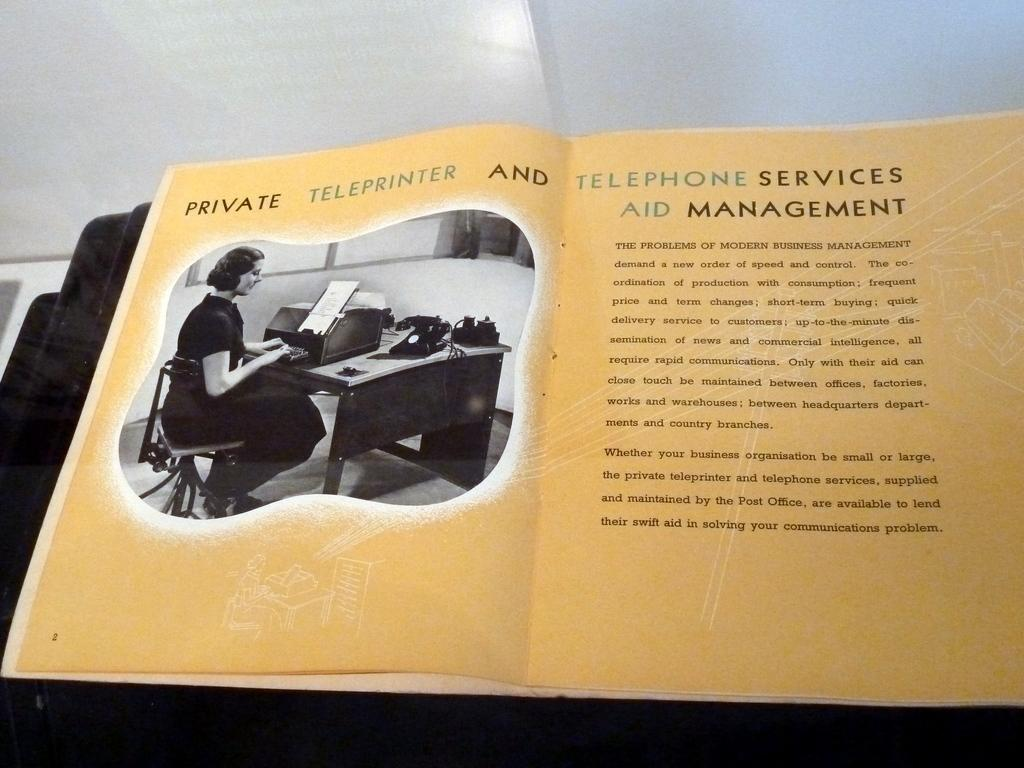<image>
Share a concise interpretation of the image provided. A book is open to a page about Private Teleprinter and Telephone services Aid Management. 